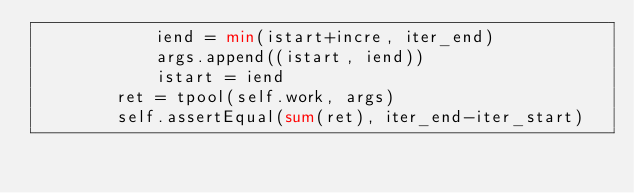<code> <loc_0><loc_0><loc_500><loc_500><_Python_>            iend = min(istart+incre, iter_end)
            args.append((istart, iend))
            istart = iend
        ret = tpool(self.work, args)
        self.assertEqual(sum(ret), iter_end-iter_start)
</code> 